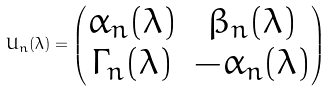Convert formula to latex. <formula><loc_0><loc_0><loc_500><loc_500>U _ { n } ( \lambda ) = \left ( \begin{matrix} \alpha _ { n } ( \lambda ) & \beta _ { n } ( \lambda ) \\ \Gamma _ { n } ( \lambda ) & - \alpha _ { n } ( \lambda ) \end{matrix} \right )</formula> 